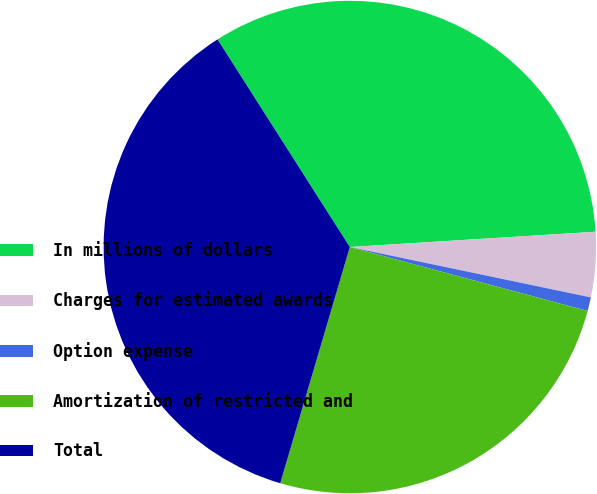<chart> <loc_0><loc_0><loc_500><loc_500><pie_chart><fcel>In millions of dollars<fcel>Charges for estimated awards<fcel>Option expense<fcel>Amortization of restricted and<fcel>Total<nl><fcel>33.04%<fcel>4.27%<fcel>0.9%<fcel>25.38%<fcel>36.41%<nl></chart> 